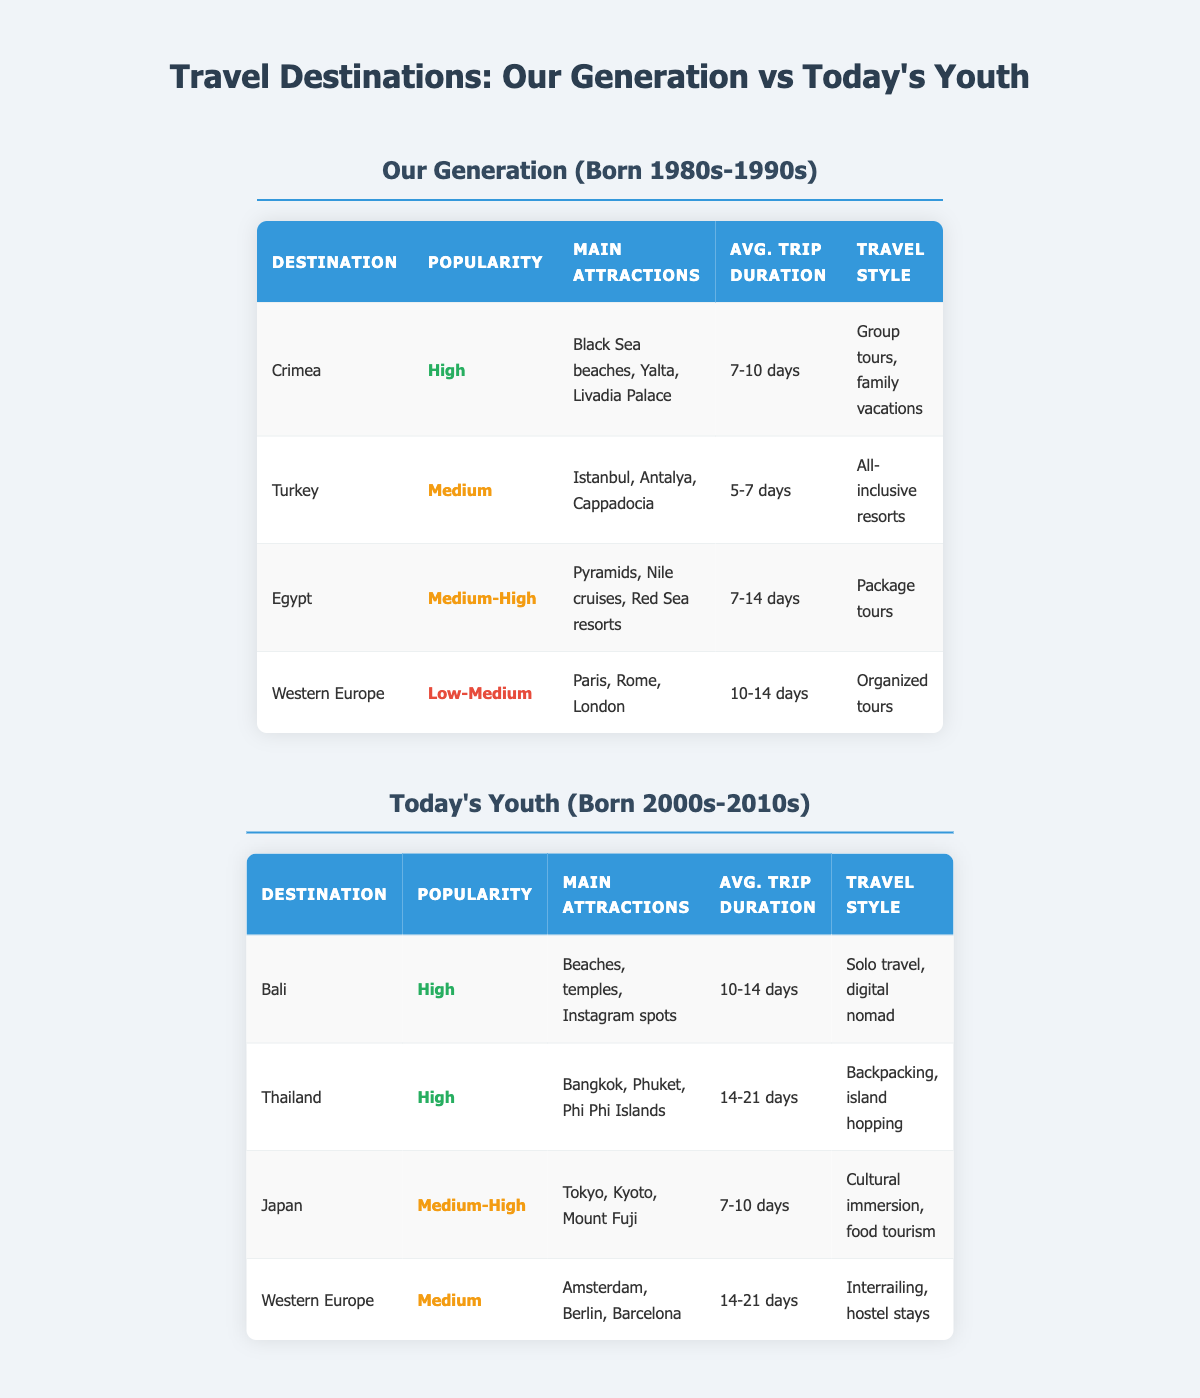What are the main attractions of Crimea? According to the table, the main attractions of Crimea are "Black Sea beaches, Yalta, Livadia Palace."
Answer: Black Sea beaches, Yalta, Livadia Palace Which destination has the highest popularity among today's youth? The table shows that both Bali and Thailand have a popularity rating of "High," indicating that they are the most favored destinations among today's youth.
Answer: Bali and Thailand Is the average trip duration for Japan longer than for Turkey? From the table, Japan has an average trip duration of "7-10 days," and Turkey has "5-7 days." Since 10 days is longer than 7 days, Japan's duration is longer than Turkey's.
Answer: Yes How many days do today's youth typically spend traveling to Thailand? The table indicates that today's youth spend "14-21 days" traveling to Thailand.
Answer: 14-21 days Which destination has seen a decline in popularity from our generation to today's youth? Both generations have Western Europe listed, with our generation noting a popularity of "Low-Medium" and today's youth showing "Medium." This indicates a rise, not decline. The other destinations are different, so the one with continuity is Western Europe, showing a decline in popularity.
Answer: Western Europe What is the difference in average trip duration between Crimea and today's youth favorite, Bali? Crimea's average trip duration is "7-10 days" while Bali's is "10-14 days." The minimum difference (10 - 7 = 3) indicates Bali's trips are at least 3 days longer. The maximum difference (14 - 10 = 4) indicates it could be up to 4 days longer depending on the duration of each trip. Overall, Bali's trips are longer.
Answer: 3-4 days Is the travel style for Eastern European destinations the same for both generations? The table indicates that Western Europe has a travel style of "Organized tours" for our generation and "Interrailing, hostel stays" for today’s youth, showing a clear difference.
Answer: No What percentage of destinations favored by our generation have a high popularity rating? Our generation has 4 destinations listed, with Crimea having a "High" rating. Therefore, one out of four destinations is a high popularity rating, which is 25%.
Answer: 25% Which travel style is predominant among today's youth compared to our generation? For today's youth, the predominant travel styles include "Solo travel, digital nomad" and "Backpacking, island hopping." In contrast, our generation favors "Group tours, family vacations" and "All-inclusive resorts." This shows a shift towards more independent and flexible travel styles today.
Answer: More independent styles 